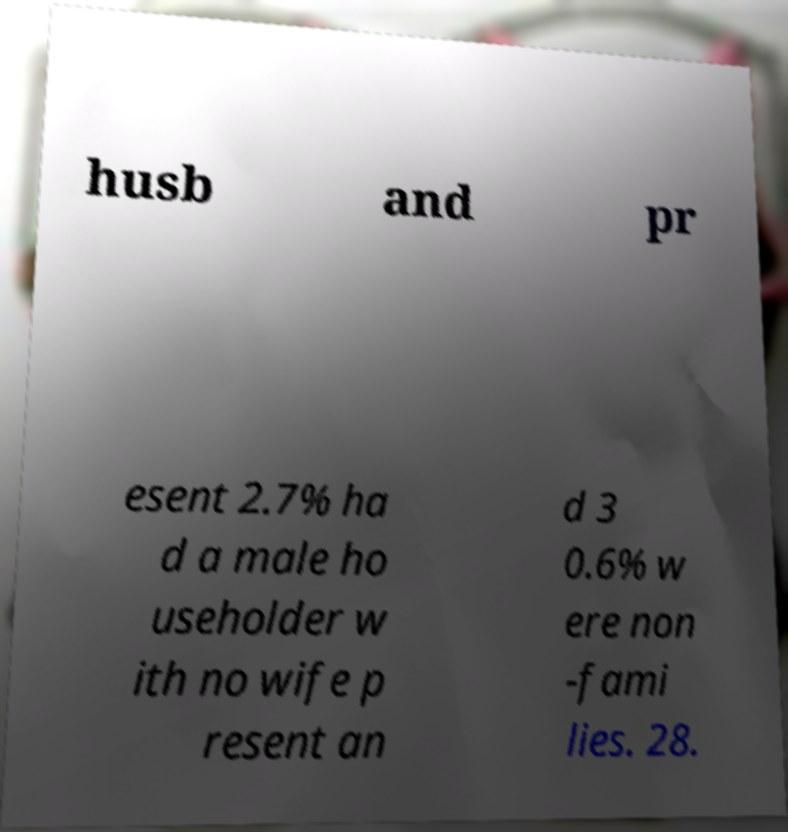I need the written content from this picture converted into text. Can you do that? husb and pr esent 2.7% ha d a male ho useholder w ith no wife p resent an d 3 0.6% w ere non -fami lies. 28. 